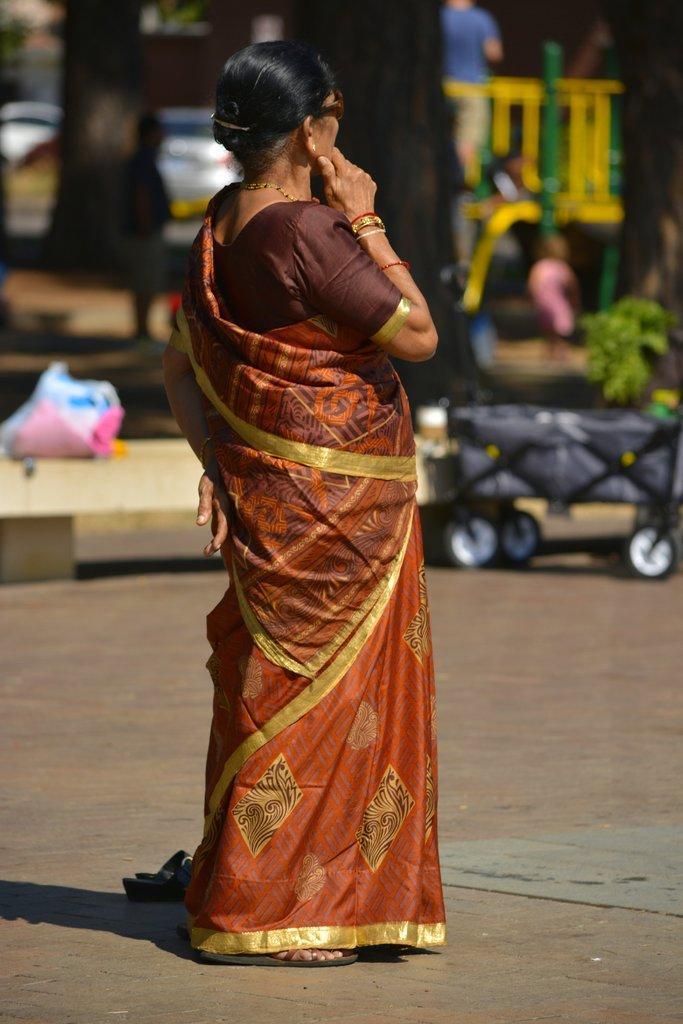In one or two sentences, can you explain what this image depicts? In the image we can see a woman standing, she is wearing saree, bangles, neck chain and goggles. This is a footpath, plant, fence, vehicle and the background is blurred. 